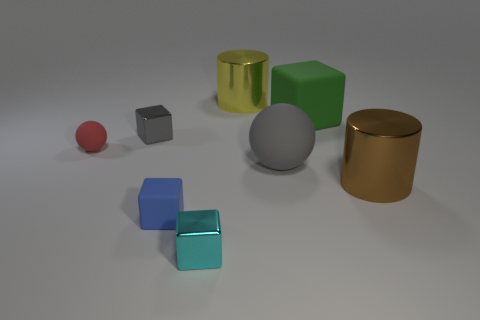Add 1 tiny brown matte cylinders. How many objects exist? 9 Subtract all cylinders. How many objects are left? 6 Add 5 gray things. How many gray things exist? 7 Subtract 0 purple cylinders. How many objects are left? 8 Subtract all large metal cylinders. Subtract all gray balls. How many objects are left? 5 Add 6 cyan metallic things. How many cyan metallic things are left? 7 